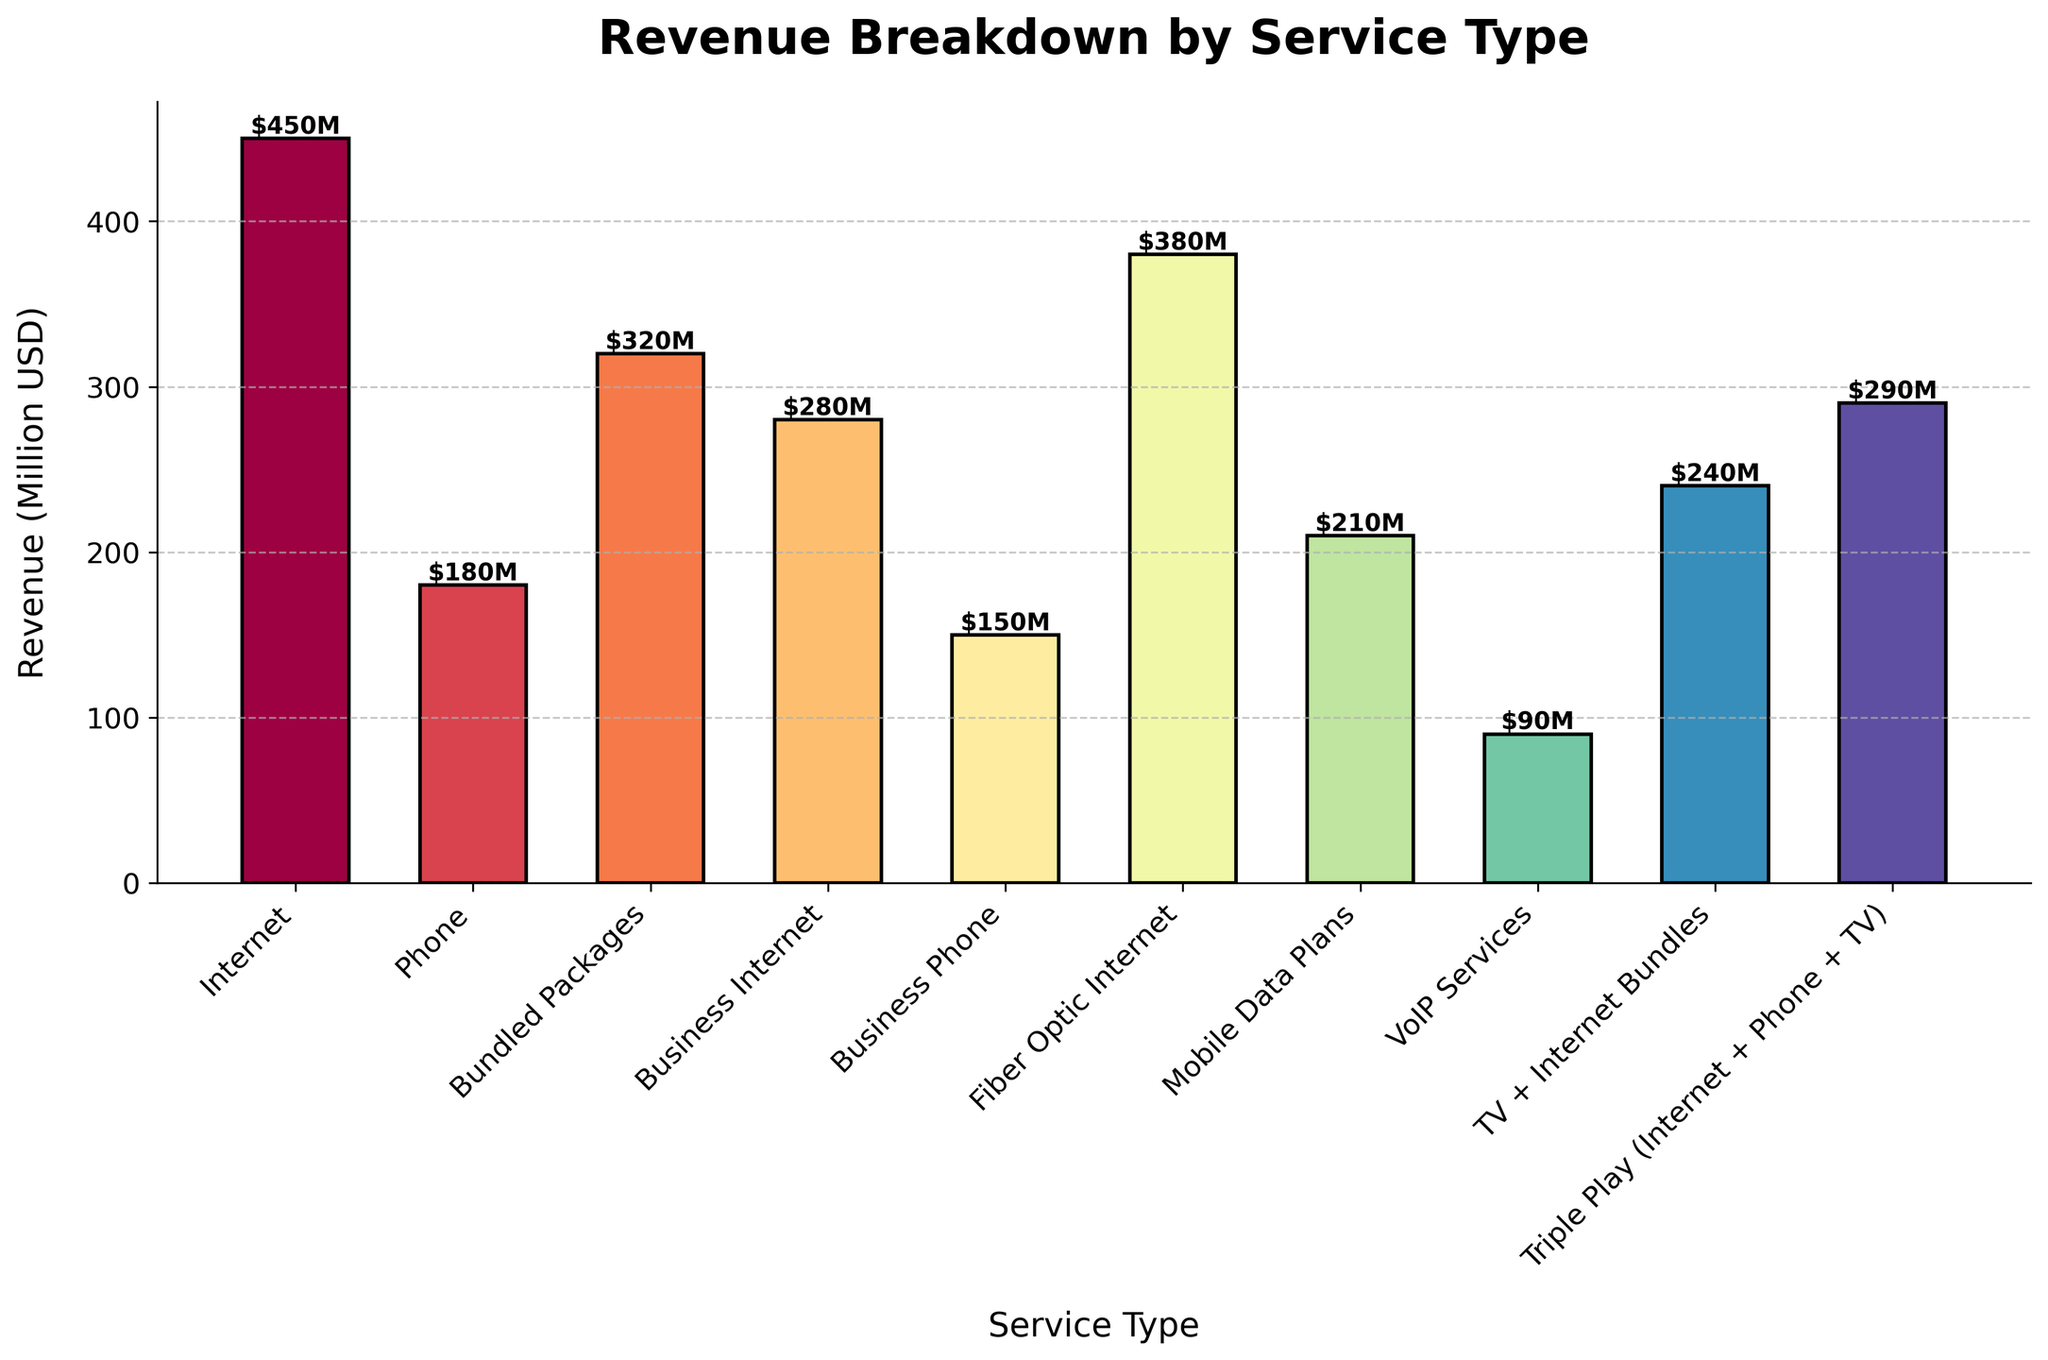What's the total revenue generated from Business-related services (Business Internet and Business Phone)? Sum the revenues from Business Internet (280 million USD) and Business Phone (150 million USD). The total revenue is 280 + 150 = 430 million USD.
Answer: 430 million USD Which service type generates the highest revenue? Examine the height of each bar and identify the tallest one, which corresponds to Internet services with 450 million USD revenue.
Answer: Internet Which service type earned less revenue: VoIP Services or Mobile Data Plans? Compare the heights of the bars for VoIP Services (90 million USD) and Mobile Data Plans (210 million USD). VoIP Services has less revenue.
Answer: VoIP Services How much more revenue does Fiber Optic Internet generate compared to Phone services? Subtract the revenue of Phone services (180 million USD) from the revenue of Fiber Optic Internet (380 million USD). The difference is 380 - 180 = 200 million USD.
Answer: 200 million USD What is the average revenue of the services related to internet specifically (Internet, Fiber Optic Internet, Business Internet, and TV + Internet Bundles)? Sum the revenues from Internet (450 million USD), Fiber Optic Internet (380 million USD), Business Internet (280 million USD), and TV + Internet Bundles (240 million USD). Then divide by the number of services (4). The calculation is (450 + 380 + 280 + 240) / 4 = 1350 / 4 = 337.5 million USD.
Answer: 337.5 million USD How many services generate a revenue higher than 200 million USD? Identify and count the bars with heights corresponding to revenues higher than 200 million USD. The services are Internet, Bundled Packages, Business Internet, Fiber Optic Internet, Mobile Data Plans, TV + Internet Bundles, and Triple Play, making a total of 7 services.
Answer: 7 Which service type has a visually similar color to Business Phone services? Observe the bars and note that the TV + Internet Bundles have a color similar to the Business Phone's bar.
Answer: TV + Internet Bundles Is the revenue from Triple Play services higher or lower than TV + Internet Bundles? Compare the heights of the bars for Triple Play (290 million USD) and TV + Internet Bundles (240 million USD). Triple Play has higher revenue.
Answer: Higher What percentage of the total revenue is contributed by Mobile Data Plans? Calculate the total revenue of all services and then find the percentage of the revenue from Mobile Data Plans. Total revenue is 450 + 180 + 320 + 280 + 150 + 380 + 210 + 90 + 240 + 290 = 2590 million USD. The percentage is (210 / 2590) * 100 ≈ 8.11%.
Answer: 8.11% Rank all services in descending order of revenue. Arrange the services from highest to lowest based on their revenue values: Internet (450), Fiber Optic Internet (380), Bundled Packages (320), Triple Play (290), Business Internet (280), TV + Internet Bundles (240), Mobile Data Plans (210), Phone (180), Business Phone (150), VoIP Services (90).
Answer: Internet, Fiber Optic Internet, Bundled Packages, Triple Play, Business Internet, TV + Internet Bundles, Mobile Data Plans, Phone, Business Phone, VoIP Services 